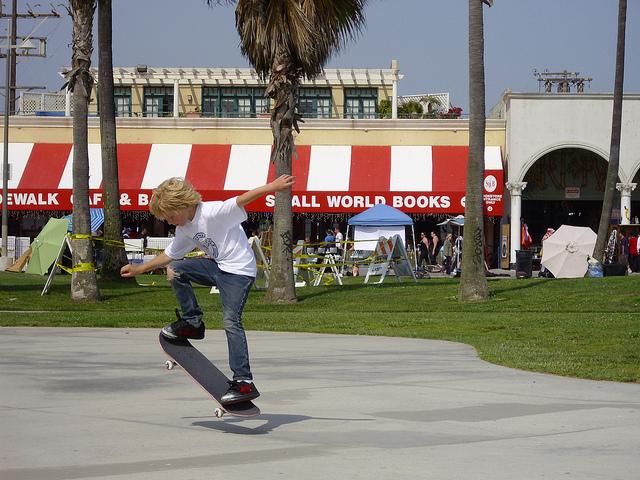Is this a carnival?
Be succinct. No. Where is the boy skateboarding?
Keep it brief. Sidewalk. Is this child wearing any protective gear?
Give a very brief answer. No. Are there any palm trees?
Be succinct. Yes. 